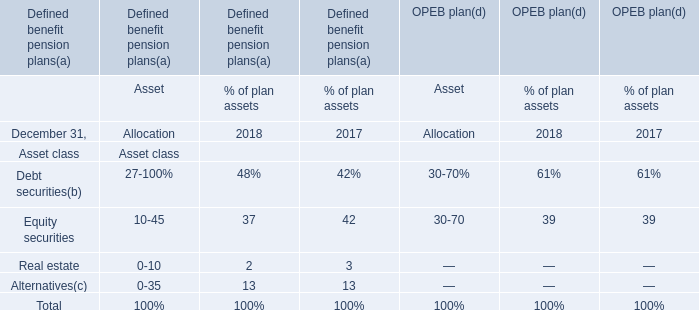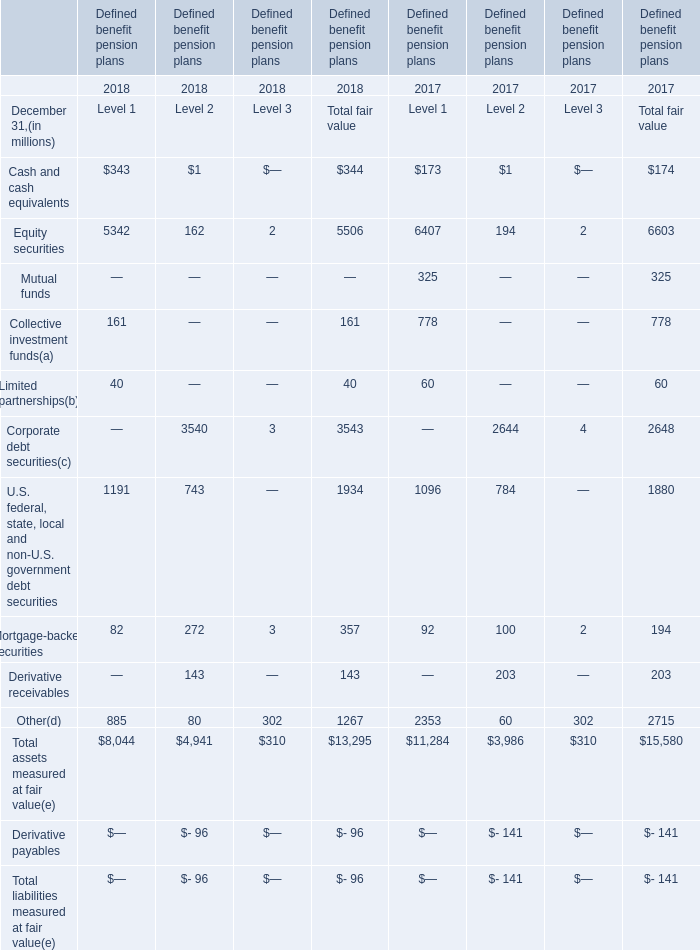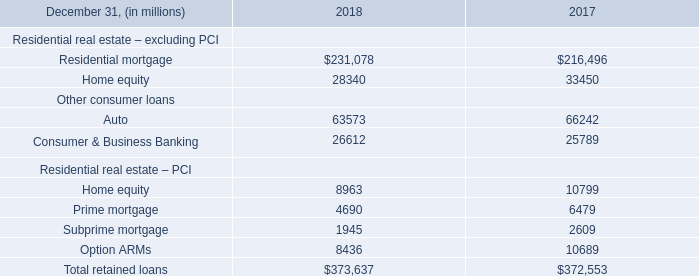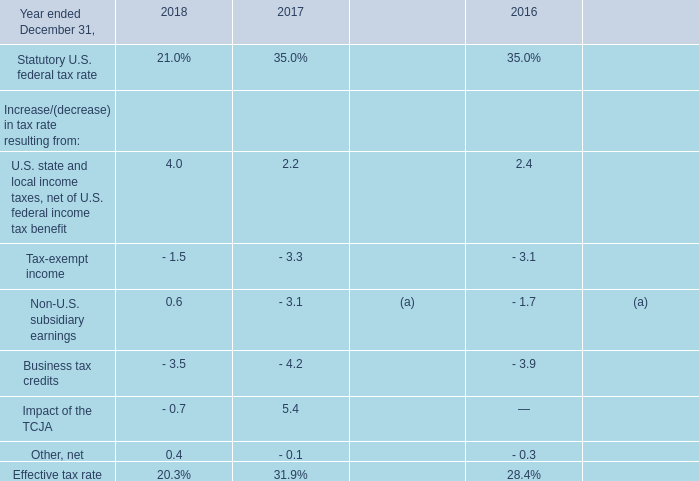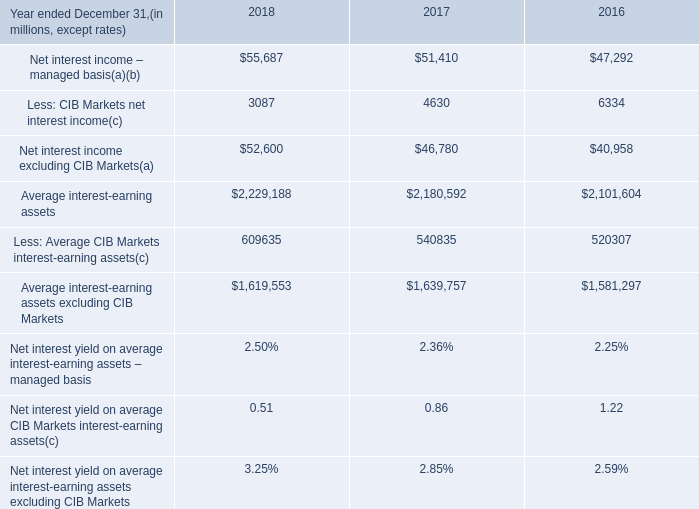Which year is the fair value of the Corporate debt securities of Level 2 higher? 
Answer: 2018. 